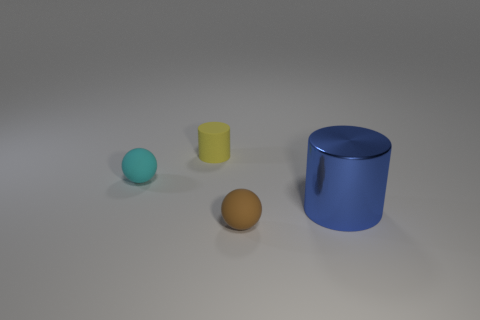Are there fewer tiny yellow matte cylinders than brown shiny cylinders?
Ensure brevity in your answer.  No. There is a small rubber thing that is in front of the small matte ball that is on the left side of the rubber ball that is in front of the large blue object; what color is it?
Offer a very short reply. Brown. Does the blue cylinder have the same material as the tiny cyan thing?
Keep it short and to the point. No. There is a yellow matte object; what number of objects are on the right side of it?
Make the answer very short. 2. There is a yellow rubber object that is the same shape as the big shiny object; what size is it?
Provide a short and direct response. Small. What number of green objects are either small objects or tiny cylinders?
Your answer should be compact. 0. How many metal cylinders are right of the matte sphere in front of the big blue metallic object?
Your answer should be compact. 1. What number of other objects are there of the same shape as the small brown thing?
Make the answer very short. 1. How many rubber things have the same color as the metallic cylinder?
Keep it short and to the point. 0. What color is the other sphere that is made of the same material as the cyan sphere?
Your response must be concise. Brown. 